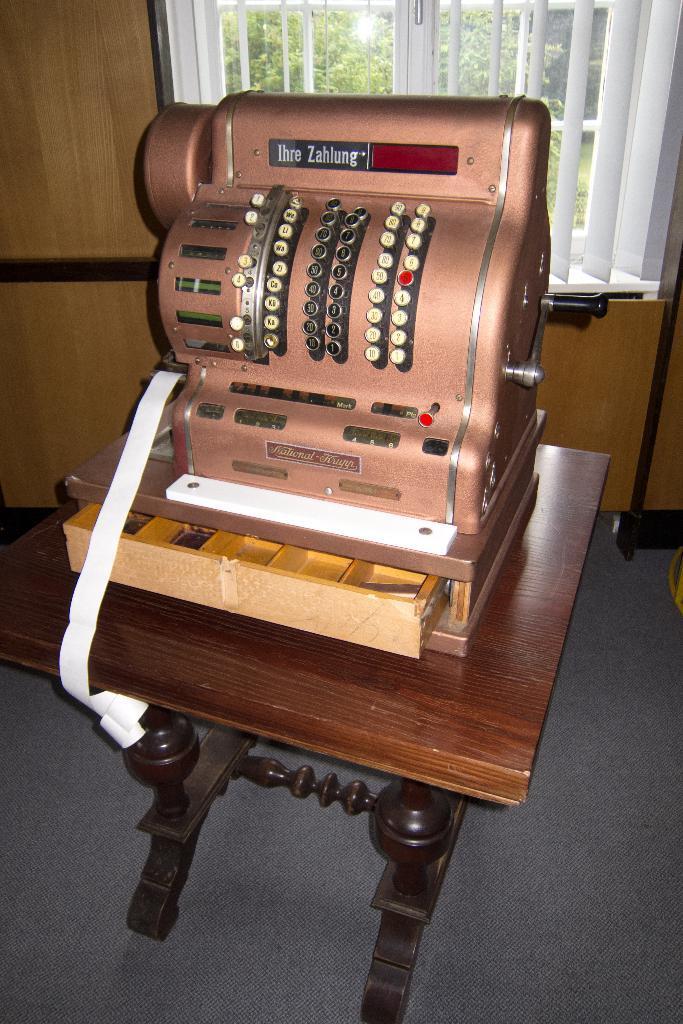In one or two sentences, can you explain what this image depicts? In this image we can see a machine on the table, also we can see the wall and a window, through the window we can see some trees. 